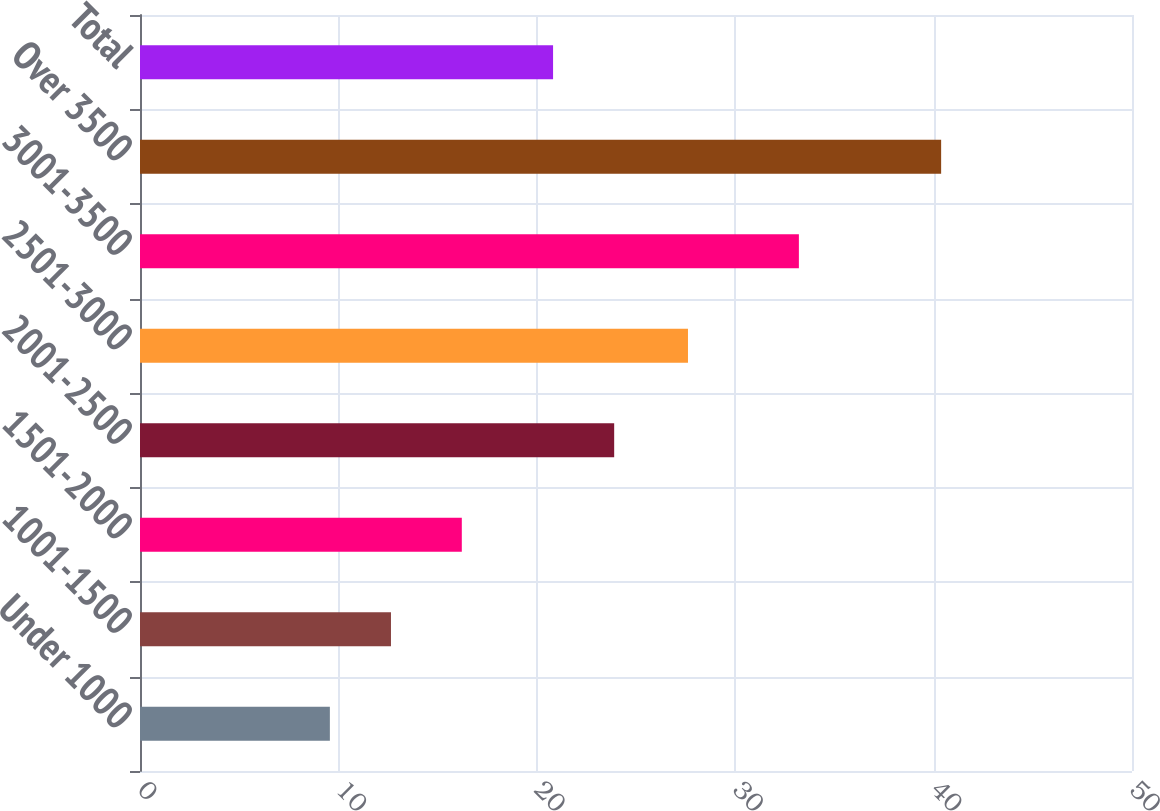Convert chart. <chart><loc_0><loc_0><loc_500><loc_500><bar_chart><fcel>Under 1000<fcel>1001-1500<fcel>1501-2000<fcel>2001-2500<fcel>2501-3000<fcel>3001-3500<fcel>Over 3500<fcel>Total<nl><fcel>9.57<fcel>12.65<fcel>16.22<fcel>23.9<fcel>27.62<fcel>33.21<fcel>40.38<fcel>20.82<nl></chart> 